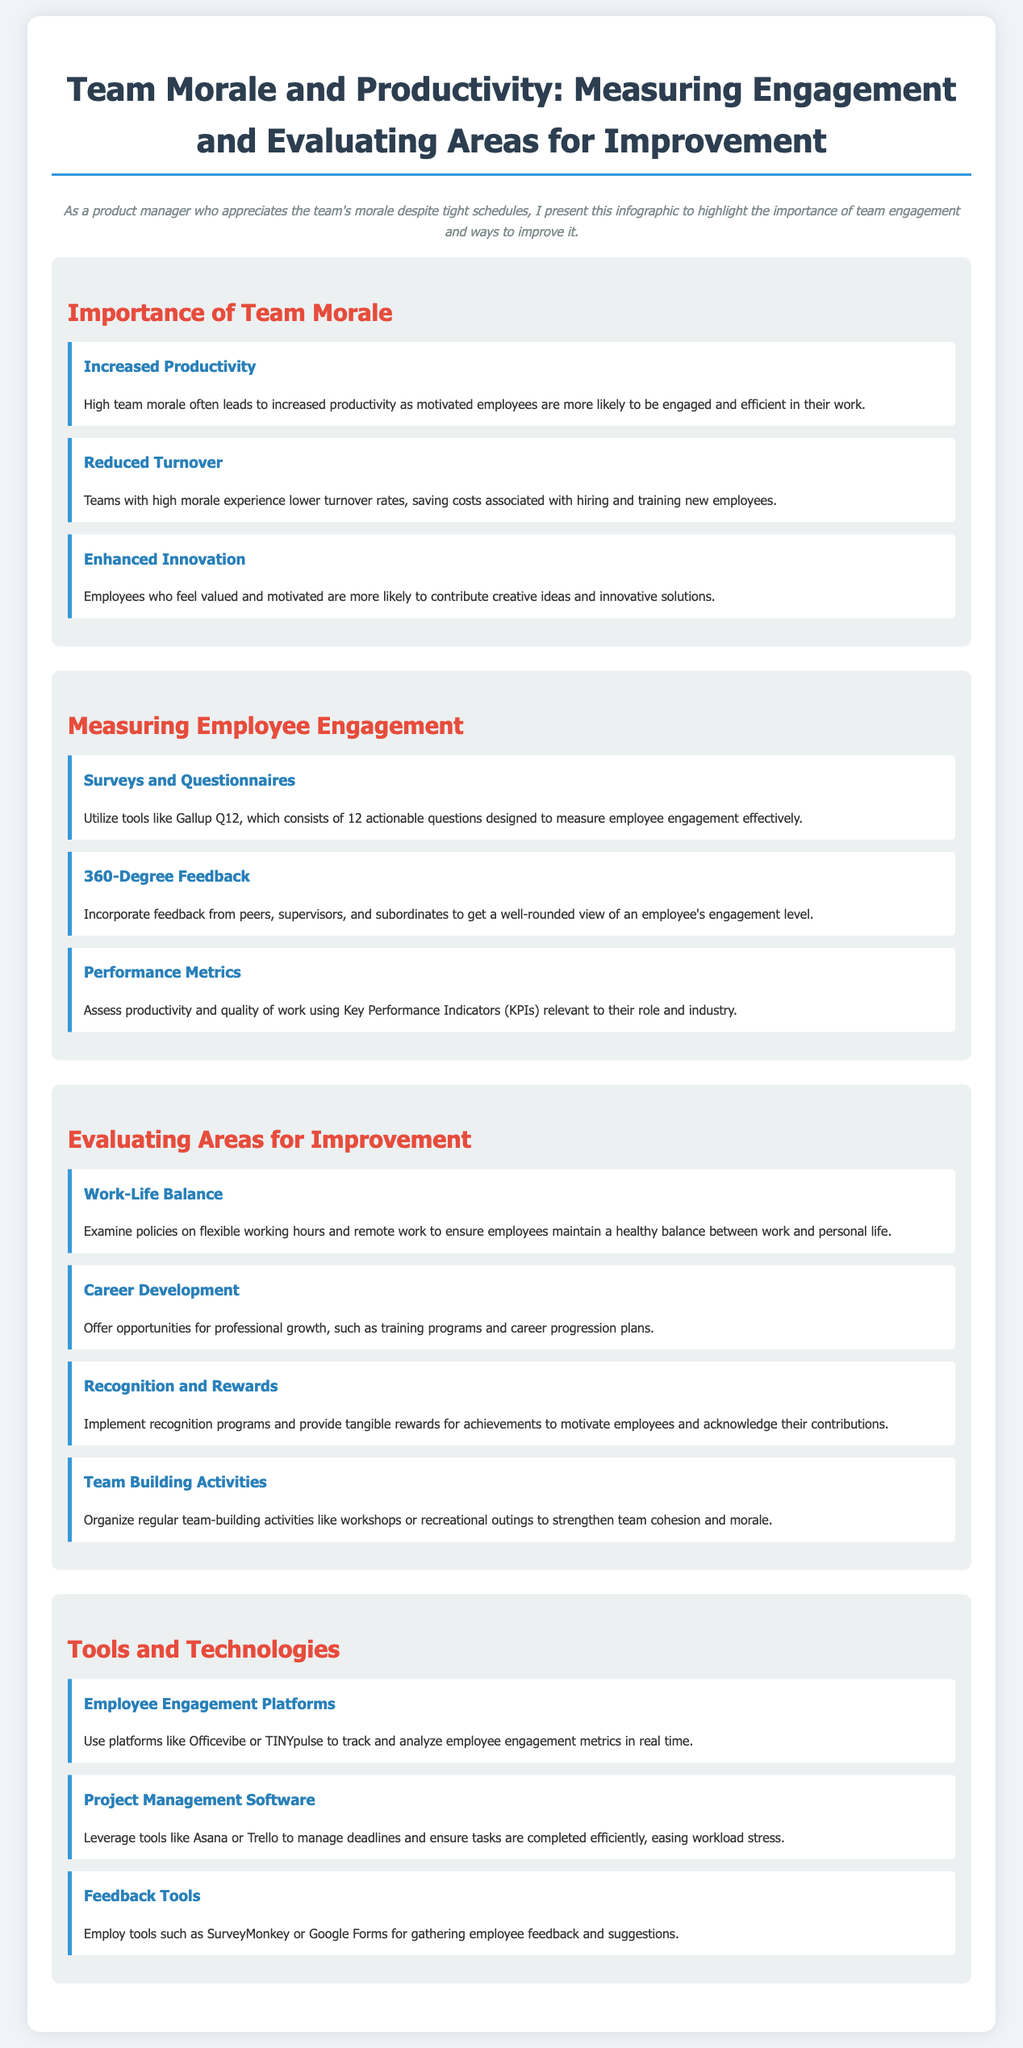What are the three main benefits of high team morale? The document lists three benefits: Increased Productivity, Reduced Turnover, and Enhanced Innovation.
Answer: Increased Productivity, Reduced Turnover, Enhanced Innovation What tool is suggested for measuring employee engagement? The document mentions Gallup Q12 as a tool to measure employee engagement effectively.
Answer: Gallup Q12 What is one area for improvement related to employee policies? The document states that examining policies on flexible working hours and remote work is an area for improvement.
Answer: Work-Life Balance Which technology is recommended for tracking employee engagement metrics? The document recommends using platforms like Officevibe or TINYpulse to track and analyze employee engagement metrics.
Answer: Officevibe or TINYpulse What type of feedback tool is mentioned in the infographic? The document mentions SurveyMonkey or Google Forms as tools for gathering employee feedback and suggestions.
Answer: SurveyMonkey or Google Forms What is a proposed activity to strengthen team morale? Organizing regular team-building activities like workshops or recreational outings is suggested to strengthen team morale.
Answer: Team Building Activities Which two project management tools are recommended in the document? The document lists Asana and Trello as project management software to manage deadlines.
Answer: Asana and Trello What are the three sections of the infographic? The infographic is divided into sections: Importance of Team Morale, Measuring Employee Engagement, and Evaluating Areas for Improvement.
Answer: Importance of Team Morale, Measuring Employee Engagement, Evaluating Areas for Improvement What is the purpose of the infographic? The document states it highlights the importance of team engagement and ways to improve it, emphasizing team morale despite tight schedules.
Answer: Highlight the importance of team engagement and ways to improve it 